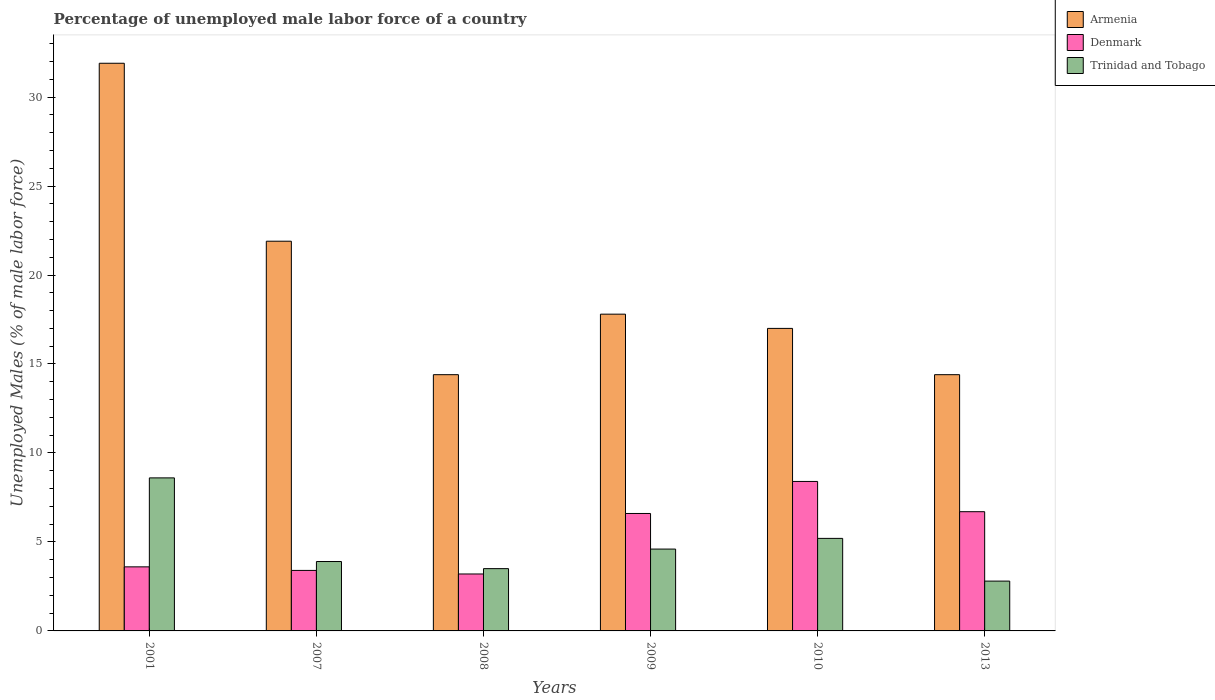How many different coloured bars are there?
Make the answer very short. 3. How many groups of bars are there?
Provide a succinct answer. 6. Are the number of bars per tick equal to the number of legend labels?
Your response must be concise. Yes. How many bars are there on the 2nd tick from the left?
Provide a short and direct response. 3. In how many cases, is the number of bars for a given year not equal to the number of legend labels?
Give a very brief answer. 0. What is the percentage of unemployed male labor force in Armenia in 2013?
Your response must be concise. 14.4. Across all years, what is the maximum percentage of unemployed male labor force in Denmark?
Offer a terse response. 8.4. Across all years, what is the minimum percentage of unemployed male labor force in Trinidad and Tobago?
Provide a short and direct response. 2.8. In which year was the percentage of unemployed male labor force in Trinidad and Tobago maximum?
Your answer should be very brief. 2001. In which year was the percentage of unemployed male labor force in Trinidad and Tobago minimum?
Ensure brevity in your answer.  2013. What is the total percentage of unemployed male labor force in Trinidad and Tobago in the graph?
Make the answer very short. 28.6. What is the difference between the percentage of unemployed male labor force in Trinidad and Tobago in 2001 and that in 2010?
Provide a succinct answer. 3.4. What is the difference between the percentage of unemployed male labor force in Armenia in 2007 and the percentage of unemployed male labor force in Trinidad and Tobago in 2008?
Provide a short and direct response. 18.4. What is the average percentage of unemployed male labor force in Armenia per year?
Provide a succinct answer. 19.57. In the year 2010, what is the difference between the percentage of unemployed male labor force in Armenia and percentage of unemployed male labor force in Denmark?
Provide a succinct answer. 8.6. In how many years, is the percentage of unemployed male labor force in Armenia greater than 9 %?
Offer a very short reply. 6. What is the ratio of the percentage of unemployed male labor force in Denmark in 2001 to that in 2010?
Keep it short and to the point. 0.43. Is the percentage of unemployed male labor force in Trinidad and Tobago in 2010 less than that in 2013?
Your response must be concise. No. What is the difference between the highest and the second highest percentage of unemployed male labor force in Armenia?
Your answer should be compact. 10. What is the difference between the highest and the lowest percentage of unemployed male labor force in Armenia?
Offer a very short reply. 17.5. In how many years, is the percentage of unemployed male labor force in Armenia greater than the average percentage of unemployed male labor force in Armenia taken over all years?
Provide a succinct answer. 2. Is the sum of the percentage of unemployed male labor force in Armenia in 2007 and 2008 greater than the maximum percentage of unemployed male labor force in Denmark across all years?
Keep it short and to the point. Yes. What does the 3rd bar from the left in 2001 represents?
Your response must be concise. Trinidad and Tobago. What does the 1st bar from the right in 2007 represents?
Ensure brevity in your answer.  Trinidad and Tobago. How many bars are there?
Provide a succinct answer. 18. Are all the bars in the graph horizontal?
Provide a short and direct response. No. How many years are there in the graph?
Offer a terse response. 6. Are the values on the major ticks of Y-axis written in scientific E-notation?
Provide a succinct answer. No. Does the graph contain any zero values?
Keep it short and to the point. No. Does the graph contain grids?
Keep it short and to the point. No. Where does the legend appear in the graph?
Provide a short and direct response. Top right. How many legend labels are there?
Make the answer very short. 3. How are the legend labels stacked?
Ensure brevity in your answer.  Vertical. What is the title of the graph?
Give a very brief answer. Percentage of unemployed male labor force of a country. Does "Bosnia and Herzegovina" appear as one of the legend labels in the graph?
Ensure brevity in your answer.  No. What is the label or title of the Y-axis?
Ensure brevity in your answer.  Unemployed Males (% of male labor force). What is the Unemployed Males (% of male labor force) of Armenia in 2001?
Your response must be concise. 31.9. What is the Unemployed Males (% of male labor force) of Denmark in 2001?
Your response must be concise. 3.6. What is the Unemployed Males (% of male labor force) of Trinidad and Tobago in 2001?
Your answer should be very brief. 8.6. What is the Unemployed Males (% of male labor force) in Armenia in 2007?
Offer a very short reply. 21.9. What is the Unemployed Males (% of male labor force) in Denmark in 2007?
Your response must be concise. 3.4. What is the Unemployed Males (% of male labor force) of Trinidad and Tobago in 2007?
Give a very brief answer. 3.9. What is the Unemployed Males (% of male labor force) of Armenia in 2008?
Make the answer very short. 14.4. What is the Unemployed Males (% of male labor force) of Denmark in 2008?
Offer a very short reply. 3.2. What is the Unemployed Males (% of male labor force) of Trinidad and Tobago in 2008?
Your answer should be compact. 3.5. What is the Unemployed Males (% of male labor force) in Armenia in 2009?
Keep it short and to the point. 17.8. What is the Unemployed Males (% of male labor force) in Denmark in 2009?
Your answer should be compact. 6.6. What is the Unemployed Males (% of male labor force) in Trinidad and Tobago in 2009?
Make the answer very short. 4.6. What is the Unemployed Males (% of male labor force) in Denmark in 2010?
Provide a short and direct response. 8.4. What is the Unemployed Males (% of male labor force) of Trinidad and Tobago in 2010?
Your answer should be very brief. 5.2. What is the Unemployed Males (% of male labor force) in Armenia in 2013?
Make the answer very short. 14.4. What is the Unemployed Males (% of male labor force) of Denmark in 2013?
Your answer should be compact. 6.7. What is the Unemployed Males (% of male labor force) of Trinidad and Tobago in 2013?
Make the answer very short. 2.8. Across all years, what is the maximum Unemployed Males (% of male labor force) in Armenia?
Make the answer very short. 31.9. Across all years, what is the maximum Unemployed Males (% of male labor force) of Denmark?
Your answer should be compact. 8.4. Across all years, what is the maximum Unemployed Males (% of male labor force) of Trinidad and Tobago?
Ensure brevity in your answer.  8.6. Across all years, what is the minimum Unemployed Males (% of male labor force) in Armenia?
Offer a terse response. 14.4. Across all years, what is the minimum Unemployed Males (% of male labor force) of Denmark?
Ensure brevity in your answer.  3.2. Across all years, what is the minimum Unemployed Males (% of male labor force) in Trinidad and Tobago?
Offer a very short reply. 2.8. What is the total Unemployed Males (% of male labor force) of Armenia in the graph?
Your response must be concise. 117.4. What is the total Unemployed Males (% of male labor force) of Denmark in the graph?
Offer a very short reply. 31.9. What is the total Unemployed Males (% of male labor force) in Trinidad and Tobago in the graph?
Make the answer very short. 28.6. What is the difference between the Unemployed Males (% of male labor force) in Armenia in 2001 and that in 2007?
Offer a very short reply. 10. What is the difference between the Unemployed Males (% of male labor force) in Denmark in 2001 and that in 2007?
Your answer should be very brief. 0.2. What is the difference between the Unemployed Males (% of male labor force) of Trinidad and Tobago in 2001 and that in 2007?
Provide a short and direct response. 4.7. What is the difference between the Unemployed Males (% of male labor force) in Armenia in 2001 and that in 2008?
Keep it short and to the point. 17.5. What is the difference between the Unemployed Males (% of male labor force) in Denmark in 2001 and that in 2008?
Provide a short and direct response. 0.4. What is the difference between the Unemployed Males (% of male labor force) of Armenia in 2001 and that in 2009?
Your answer should be compact. 14.1. What is the difference between the Unemployed Males (% of male labor force) in Armenia in 2001 and that in 2010?
Make the answer very short. 14.9. What is the difference between the Unemployed Males (% of male labor force) in Denmark in 2001 and that in 2010?
Your answer should be very brief. -4.8. What is the difference between the Unemployed Males (% of male labor force) of Armenia in 2001 and that in 2013?
Your answer should be very brief. 17.5. What is the difference between the Unemployed Males (% of male labor force) in Armenia in 2007 and that in 2008?
Make the answer very short. 7.5. What is the difference between the Unemployed Males (% of male labor force) of Denmark in 2007 and that in 2008?
Keep it short and to the point. 0.2. What is the difference between the Unemployed Males (% of male labor force) of Trinidad and Tobago in 2007 and that in 2009?
Offer a very short reply. -0.7. What is the difference between the Unemployed Males (% of male labor force) in Armenia in 2008 and that in 2009?
Make the answer very short. -3.4. What is the difference between the Unemployed Males (% of male labor force) in Armenia in 2009 and that in 2010?
Your answer should be very brief. 0.8. What is the difference between the Unemployed Males (% of male labor force) in Denmark in 2009 and that in 2013?
Your answer should be very brief. -0.1. What is the difference between the Unemployed Males (% of male labor force) in Armenia in 2001 and the Unemployed Males (% of male labor force) in Denmark in 2007?
Provide a succinct answer. 28.5. What is the difference between the Unemployed Males (% of male labor force) in Armenia in 2001 and the Unemployed Males (% of male labor force) in Denmark in 2008?
Your response must be concise. 28.7. What is the difference between the Unemployed Males (% of male labor force) in Armenia in 2001 and the Unemployed Males (% of male labor force) in Trinidad and Tobago in 2008?
Make the answer very short. 28.4. What is the difference between the Unemployed Males (% of male labor force) of Denmark in 2001 and the Unemployed Males (% of male labor force) of Trinidad and Tobago in 2008?
Provide a short and direct response. 0.1. What is the difference between the Unemployed Males (% of male labor force) of Armenia in 2001 and the Unemployed Males (% of male labor force) of Denmark in 2009?
Offer a very short reply. 25.3. What is the difference between the Unemployed Males (% of male labor force) in Armenia in 2001 and the Unemployed Males (% of male labor force) in Trinidad and Tobago in 2009?
Your answer should be compact. 27.3. What is the difference between the Unemployed Males (% of male labor force) in Armenia in 2001 and the Unemployed Males (% of male labor force) in Trinidad and Tobago in 2010?
Offer a terse response. 26.7. What is the difference between the Unemployed Males (% of male labor force) of Denmark in 2001 and the Unemployed Males (% of male labor force) of Trinidad and Tobago in 2010?
Your answer should be very brief. -1.6. What is the difference between the Unemployed Males (% of male labor force) in Armenia in 2001 and the Unemployed Males (% of male labor force) in Denmark in 2013?
Your response must be concise. 25.2. What is the difference between the Unemployed Males (% of male labor force) of Armenia in 2001 and the Unemployed Males (% of male labor force) of Trinidad and Tobago in 2013?
Offer a terse response. 29.1. What is the difference between the Unemployed Males (% of male labor force) in Armenia in 2007 and the Unemployed Males (% of male labor force) in Trinidad and Tobago in 2008?
Keep it short and to the point. 18.4. What is the difference between the Unemployed Males (% of male labor force) of Denmark in 2007 and the Unemployed Males (% of male labor force) of Trinidad and Tobago in 2008?
Provide a succinct answer. -0.1. What is the difference between the Unemployed Males (% of male labor force) of Armenia in 2007 and the Unemployed Males (% of male labor force) of Denmark in 2009?
Provide a succinct answer. 15.3. What is the difference between the Unemployed Males (% of male labor force) of Armenia in 2007 and the Unemployed Males (% of male labor force) of Trinidad and Tobago in 2009?
Offer a very short reply. 17.3. What is the difference between the Unemployed Males (% of male labor force) in Denmark in 2007 and the Unemployed Males (% of male labor force) in Trinidad and Tobago in 2009?
Provide a succinct answer. -1.2. What is the difference between the Unemployed Males (% of male labor force) in Armenia in 2007 and the Unemployed Males (% of male labor force) in Trinidad and Tobago in 2010?
Provide a succinct answer. 16.7. What is the difference between the Unemployed Males (% of male labor force) of Denmark in 2007 and the Unemployed Males (% of male labor force) of Trinidad and Tobago in 2010?
Offer a very short reply. -1.8. What is the difference between the Unemployed Males (% of male labor force) in Armenia in 2007 and the Unemployed Males (% of male labor force) in Trinidad and Tobago in 2013?
Provide a short and direct response. 19.1. What is the difference between the Unemployed Males (% of male labor force) in Denmark in 2007 and the Unemployed Males (% of male labor force) in Trinidad and Tobago in 2013?
Your answer should be very brief. 0.6. What is the difference between the Unemployed Males (% of male labor force) of Armenia in 2008 and the Unemployed Males (% of male labor force) of Trinidad and Tobago in 2009?
Your answer should be very brief. 9.8. What is the difference between the Unemployed Males (% of male labor force) in Denmark in 2008 and the Unemployed Males (% of male labor force) in Trinidad and Tobago in 2009?
Make the answer very short. -1.4. What is the difference between the Unemployed Males (% of male labor force) in Armenia in 2008 and the Unemployed Males (% of male labor force) in Trinidad and Tobago in 2010?
Keep it short and to the point. 9.2. What is the difference between the Unemployed Males (% of male labor force) of Denmark in 2008 and the Unemployed Males (% of male labor force) of Trinidad and Tobago in 2010?
Your response must be concise. -2. What is the difference between the Unemployed Males (% of male labor force) in Armenia in 2008 and the Unemployed Males (% of male labor force) in Denmark in 2013?
Offer a terse response. 7.7. What is the difference between the Unemployed Males (% of male labor force) of Denmark in 2009 and the Unemployed Males (% of male labor force) of Trinidad and Tobago in 2013?
Offer a very short reply. 3.8. What is the difference between the Unemployed Males (% of male labor force) in Armenia in 2010 and the Unemployed Males (% of male labor force) in Denmark in 2013?
Give a very brief answer. 10.3. What is the difference between the Unemployed Males (% of male labor force) of Armenia in 2010 and the Unemployed Males (% of male labor force) of Trinidad and Tobago in 2013?
Your answer should be very brief. 14.2. What is the difference between the Unemployed Males (% of male labor force) in Denmark in 2010 and the Unemployed Males (% of male labor force) in Trinidad and Tobago in 2013?
Give a very brief answer. 5.6. What is the average Unemployed Males (% of male labor force) of Armenia per year?
Provide a succinct answer. 19.57. What is the average Unemployed Males (% of male labor force) in Denmark per year?
Offer a terse response. 5.32. What is the average Unemployed Males (% of male labor force) in Trinidad and Tobago per year?
Offer a very short reply. 4.77. In the year 2001, what is the difference between the Unemployed Males (% of male labor force) in Armenia and Unemployed Males (% of male labor force) in Denmark?
Your response must be concise. 28.3. In the year 2001, what is the difference between the Unemployed Males (% of male labor force) of Armenia and Unemployed Males (% of male labor force) of Trinidad and Tobago?
Give a very brief answer. 23.3. In the year 2001, what is the difference between the Unemployed Males (% of male labor force) of Denmark and Unemployed Males (% of male labor force) of Trinidad and Tobago?
Give a very brief answer. -5. In the year 2007, what is the difference between the Unemployed Males (% of male labor force) of Armenia and Unemployed Males (% of male labor force) of Denmark?
Your response must be concise. 18.5. In the year 2007, what is the difference between the Unemployed Males (% of male labor force) of Armenia and Unemployed Males (% of male labor force) of Trinidad and Tobago?
Offer a terse response. 18. In the year 2007, what is the difference between the Unemployed Males (% of male labor force) in Denmark and Unemployed Males (% of male labor force) in Trinidad and Tobago?
Give a very brief answer. -0.5. In the year 2008, what is the difference between the Unemployed Males (% of male labor force) of Armenia and Unemployed Males (% of male labor force) of Denmark?
Your response must be concise. 11.2. In the year 2009, what is the difference between the Unemployed Males (% of male labor force) in Armenia and Unemployed Males (% of male labor force) in Denmark?
Offer a very short reply. 11.2. In the year 2009, what is the difference between the Unemployed Males (% of male labor force) of Armenia and Unemployed Males (% of male labor force) of Trinidad and Tobago?
Your answer should be very brief. 13.2. In the year 2010, what is the difference between the Unemployed Males (% of male labor force) in Armenia and Unemployed Males (% of male labor force) in Trinidad and Tobago?
Offer a terse response. 11.8. In the year 2013, what is the difference between the Unemployed Males (% of male labor force) of Denmark and Unemployed Males (% of male labor force) of Trinidad and Tobago?
Offer a very short reply. 3.9. What is the ratio of the Unemployed Males (% of male labor force) of Armenia in 2001 to that in 2007?
Offer a terse response. 1.46. What is the ratio of the Unemployed Males (% of male labor force) of Denmark in 2001 to that in 2007?
Give a very brief answer. 1.06. What is the ratio of the Unemployed Males (% of male labor force) of Trinidad and Tobago in 2001 to that in 2007?
Your answer should be very brief. 2.21. What is the ratio of the Unemployed Males (% of male labor force) of Armenia in 2001 to that in 2008?
Keep it short and to the point. 2.22. What is the ratio of the Unemployed Males (% of male labor force) of Trinidad and Tobago in 2001 to that in 2008?
Offer a very short reply. 2.46. What is the ratio of the Unemployed Males (% of male labor force) in Armenia in 2001 to that in 2009?
Provide a short and direct response. 1.79. What is the ratio of the Unemployed Males (% of male labor force) in Denmark in 2001 to that in 2009?
Give a very brief answer. 0.55. What is the ratio of the Unemployed Males (% of male labor force) of Trinidad and Tobago in 2001 to that in 2009?
Give a very brief answer. 1.87. What is the ratio of the Unemployed Males (% of male labor force) of Armenia in 2001 to that in 2010?
Offer a terse response. 1.88. What is the ratio of the Unemployed Males (% of male labor force) of Denmark in 2001 to that in 2010?
Your response must be concise. 0.43. What is the ratio of the Unemployed Males (% of male labor force) in Trinidad and Tobago in 2001 to that in 2010?
Provide a succinct answer. 1.65. What is the ratio of the Unemployed Males (% of male labor force) in Armenia in 2001 to that in 2013?
Provide a short and direct response. 2.22. What is the ratio of the Unemployed Males (% of male labor force) in Denmark in 2001 to that in 2013?
Provide a succinct answer. 0.54. What is the ratio of the Unemployed Males (% of male labor force) of Trinidad and Tobago in 2001 to that in 2013?
Keep it short and to the point. 3.07. What is the ratio of the Unemployed Males (% of male labor force) in Armenia in 2007 to that in 2008?
Your response must be concise. 1.52. What is the ratio of the Unemployed Males (% of male labor force) of Denmark in 2007 to that in 2008?
Make the answer very short. 1.06. What is the ratio of the Unemployed Males (% of male labor force) in Trinidad and Tobago in 2007 to that in 2008?
Your response must be concise. 1.11. What is the ratio of the Unemployed Males (% of male labor force) in Armenia in 2007 to that in 2009?
Ensure brevity in your answer.  1.23. What is the ratio of the Unemployed Males (% of male labor force) of Denmark in 2007 to that in 2009?
Your answer should be compact. 0.52. What is the ratio of the Unemployed Males (% of male labor force) in Trinidad and Tobago in 2007 to that in 2009?
Offer a very short reply. 0.85. What is the ratio of the Unemployed Males (% of male labor force) of Armenia in 2007 to that in 2010?
Offer a very short reply. 1.29. What is the ratio of the Unemployed Males (% of male labor force) of Denmark in 2007 to that in 2010?
Make the answer very short. 0.4. What is the ratio of the Unemployed Males (% of male labor force) in Trinidad and Tobago in 2007 to that in 2010?
Offer a very short reply. 0.75. What is the ratio of the Unemployed Males (% of male labor force) of Armenia in 2007 to that in 2013?
Keep it short and to the point. 1.52. What is the ratio of the Unemployed Males (% of male labor force) in Denmark in 2007 to that in 2013?
Ensure brevity in your answer.  0.51. What is the ratio of the Unemployed Males (% of male labor force) in Trinidad and Tobago in 2007 to that in 2013?
Your answer should be compact. 1.39. What is the ratio of the Unemployed Males (% of male labor force) of Armenia in 2008 to that in 2009?
Your answer should be very brief. 0.81. What is the ratio of the Unemployed Males (% of male labor force) of Denmark in 2008 to that in 2009?
Your response must be concise. 0.48. What is the ratio of the Unemployed Males (% of male labor force) of Trinidad and Tobago in 2008 to that in 2009?
Make the answer very short. 0.76. What is the ratio of the Unemployed Males (% of male labor force) of Armenia in 2008 to that in 2010?
Provide a short and direct response. 0.85. What is the ratio of the Unemployed Males (% of male labor force) of Denmark in 2008 to that in 2010?
Ensure brevity in your answer.  0.38. What is the ratio of the Unemployed Males (% of male labor force) of Trinidad and Tobago in 2008 to that in 2010?
Make the answer very short. 0.67. What is the ratio of the Unemployed Males (% of male labor force) of Armenia in 2008 to that in 2013?
Your answer should be compact. 1. What is the ratio of the Unemployed Males (% of male labor force) of Denmark in 2008 to that in 2013?
Your answer should be very brief. 0.48. What is the ratio of the Unemployed Males (% of male labor force) in Trinidad and Tobago in 2008 to that in 2013?
Provide a short and direct response. 1.25. What is the ratio of the Unemployed Males (% of male labor force) of Armenia in 2009 to that in 2010?
Your answer should be compact. 1.05. What is the ratio of the Unemployed Males (% of male labor force) of Denmark in 2009 to that in 2010?
Ensure brevity in your answer.  0.79. What is the ratio of the Unemployed Males (% of male labor force) of Trinidad and Tobago in 2009 to that in 2010?
Provide a short and direct response. 0.88. What is the ratio of the Unemployed Males (% of male labor force) of Armenia in 2009 to that in 2013?
Ensure brevity in your answer.  1.24. What is the ratio of the Unemployed Males (% of male labor force) of Denmark in 2009 to that in 2013?
Offer a very short reply. 0.99. What is the ratio of the Unemployed Males (% of male labor force) in Trinidad and Tobago in 2009 to that in 2013?
Your answer should be very brief. 1.64. What is the ratio of the Unemployed Males (% of male labor force) of Armenia in 2010 to that in 2013?
Keep it short and to the point. 1.18. What is the ratio of the Unemployed Males (% of male labor force) of Denmark in 2010 to that in 2013?
Keep it short and to the point. 1.25. What is the ratio of the Unemployed Males (% of male labor force) of Trinidad and Tobago in 2010 to that in 2013?
Your response must be concise. 1.86. What is the difference between the highest and the second highest Unemployed Males (% of male labor force) in Armenia?
Make the answer very short. 10. What is the difference between the highest and the second highest Unemployed Males (% of male labor force) of Denmark?
Keep it short and to the point. 1.7. What is the difference between the highest and the lowest Unemployed Males (% of male labor force) of Denmark?
Your answer should be very brief. 5.2. 